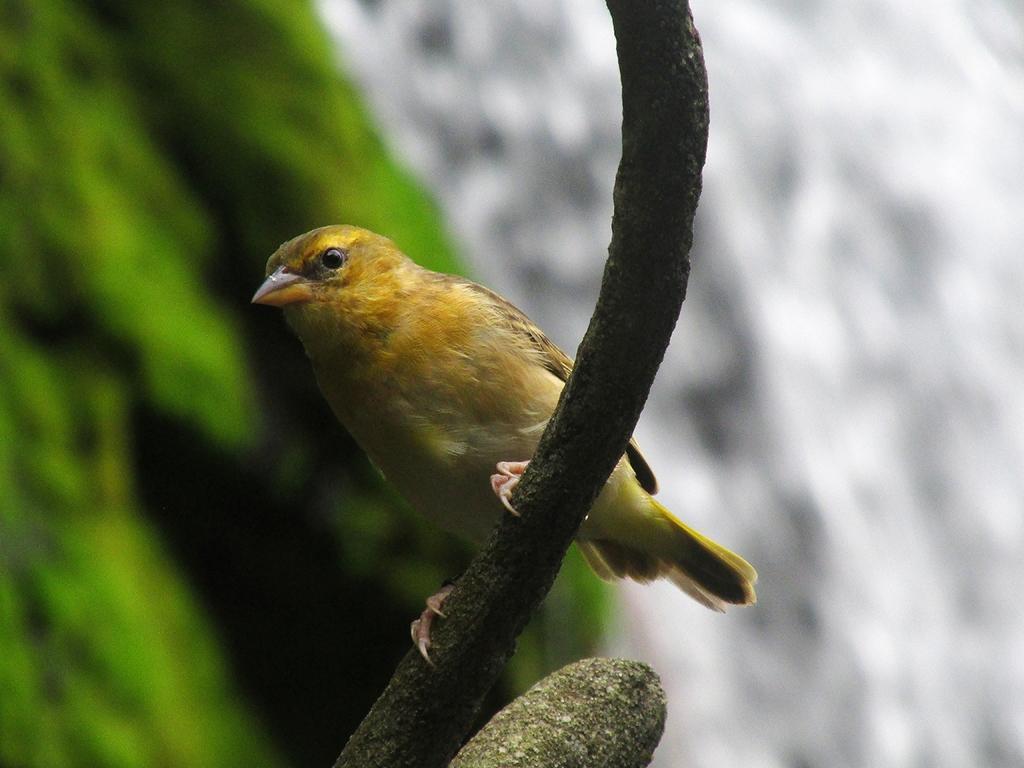In one or two sentences, can you explain what this image depicts? In this image I can see a bird which is yellow, orange, brown, green and black in color on a wooden stick. I can see the blurry background which is white, green and black in color. 